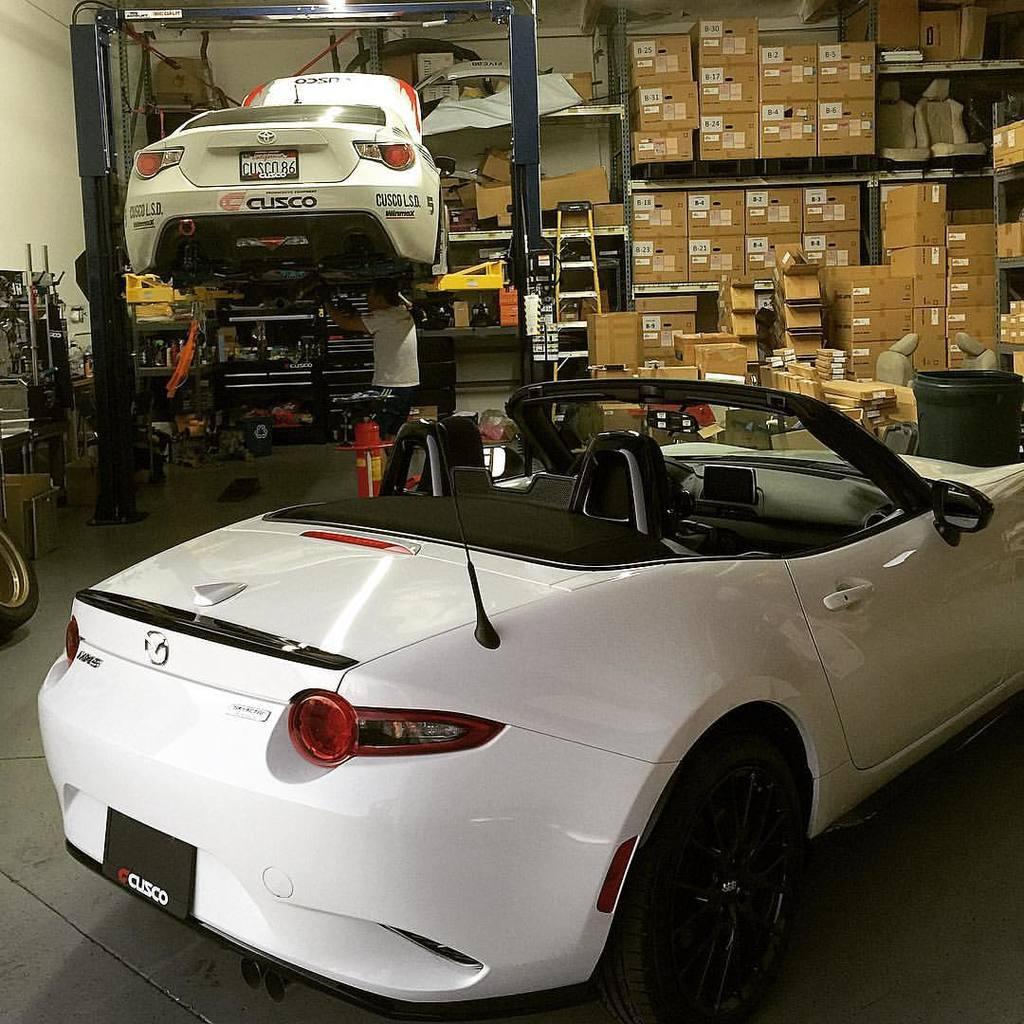Please provide a concise description of this image. In this picture there is a white car on the floor. In the top left this there is another white color car which is lifted by machine. Below that there is a man who is wearing t-shirt and trouser. In the back I can see many cotton robes was kept on the racks. On the left there is a wheel near to the table. 